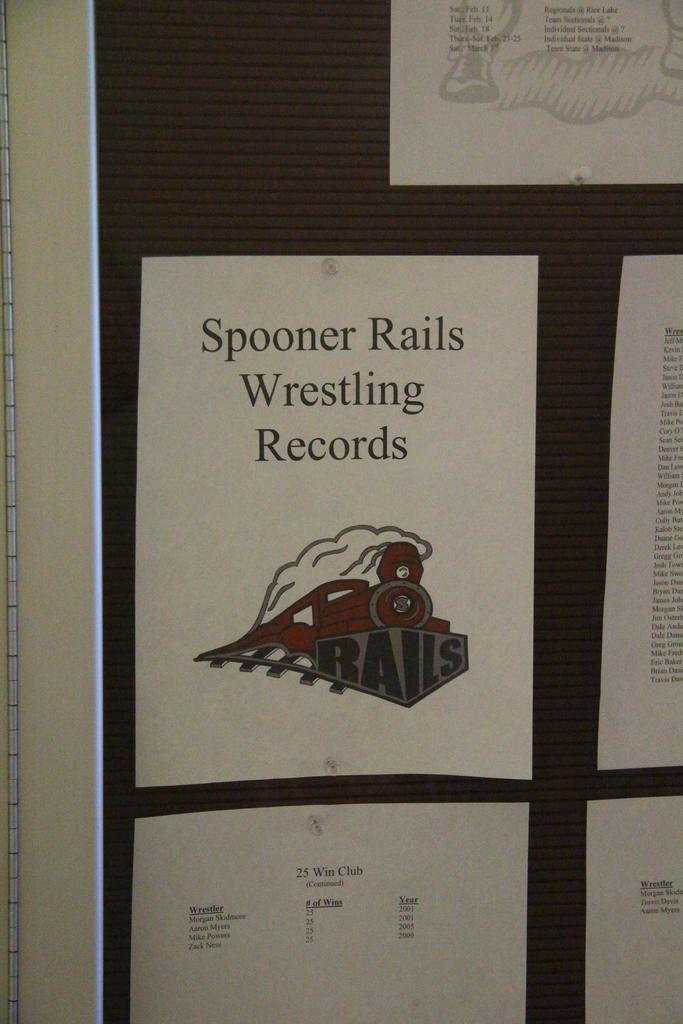Whose wrestling records are those?
Your answer should be compact. Spooner rails. What school is this for?
Your answer should be very brief. Spooner rails wrestling records. 